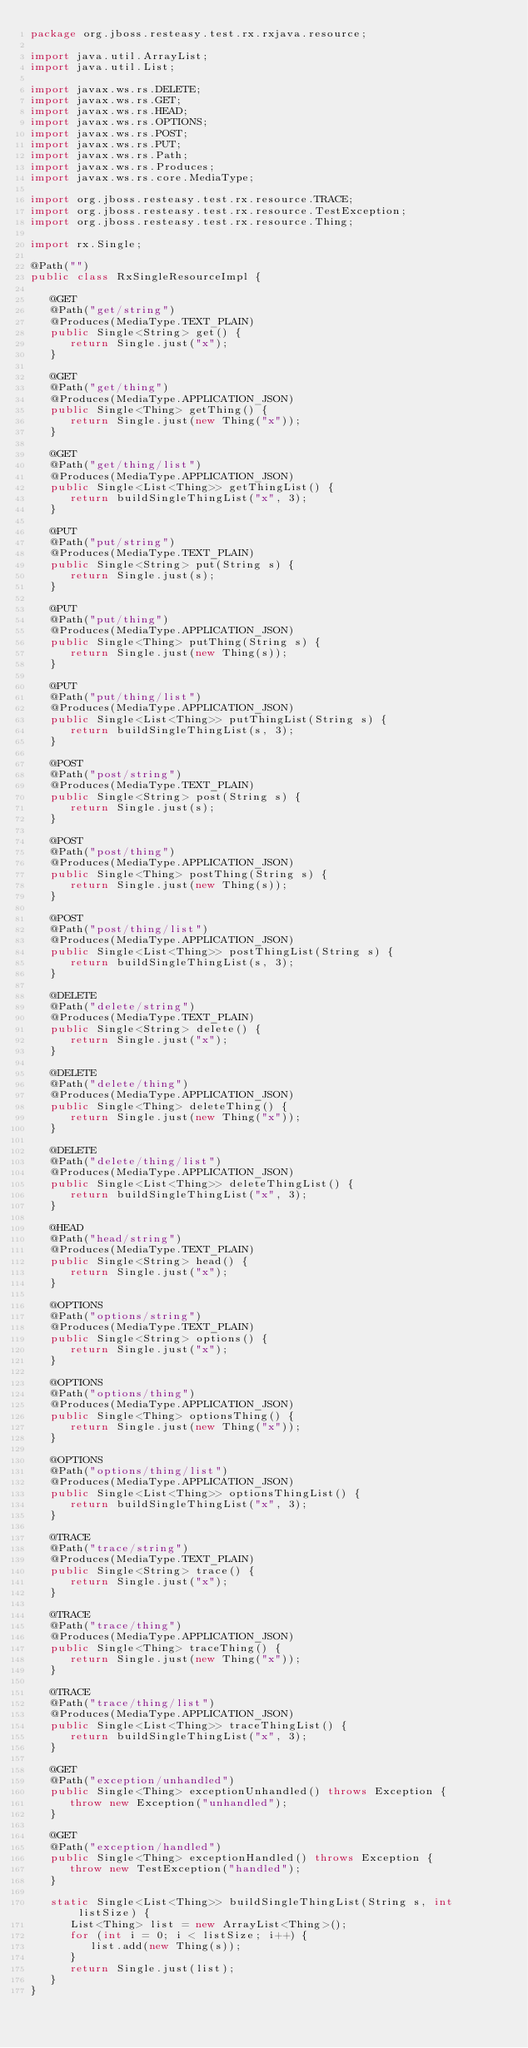<code> <loc_0><loc_0><loc_500><loc_500><_Java_>package org.jboss.resteasy.test.rx.rxjava.resource;

import java.util.ArrayList;
import java.util.List;

import javax.ws.rs.DELETE;
import javax.ws.rs.GET;
import javax.ws.rs.HEAD;
import javax.ws.rs.OPTIONS;
import javax.ws.rs.POST;
import javax.ws.rs.PUT;
import javax.ws.rs.Path;
import javax.ws.rs.Produces;
import javax.ws.rs.core.MediaType;

import org.jboss.resteasy.test.rx.resource.TRACE;
import org.jboss.resteasy.test.rx.resource.TestException;
import org.jboss.resteasy.test.rx.resource.Thing;

import rx.Single;

@Path("")
public class RxSingleResourceImpl {

   @GET
   @Path("get/string")
   @Produces(MediaType.TEXT_PLAIN)
   public Single<String> get() {
      return Single.just("x");
   }

   @GET
   @Path("get/thing")
   @Produces(MediaType.APPLICATION_JSON)
   public Single<Thing> getThing() {
      return Single.just(new Thing("x"));
   }

   @GET
   @Path("get/thing/list")
   @Produces(MediaType.APPLICATION_JSON)
   public Single<List<Thing>> getThingList() {
      return buildSingleThingList("x", 3);
   }

   @PUT
   @Path("put/string")
   @Produces(MediaType.TEXT_PLAIN)
   public Single<String> put(String s) {
      return Single.just(s);
   }

   @PUT
   @Path("put/thing")
   @Produces(MediaType.APPLICATION_JSON)
   public Single<Thing> putThing(String s) {
      return Single.just(new Thing(s));
   }

   @PUT
   @Path("put/thing/list")
   @Produces(MediaType.APPLICATION_JSON)
   public Single<List<Thing>> putThingList(String s) {
      return buildSingleThingList(s, 3);
   }

   @POST
   @Path("post/string")
   @Produces(MediaType.TEXT_PLAIN)
   public Single<String> post(String s) {
      return Single.just(s);
   }

   @POST
   @Path("post/thing")
   @Produces(MediaType.APPLICATION_JSON)
   public Single<Thing> postThing(String s) {
      return Single.just(new Thing(s));
   }

   @POST
   @Path("post/thing/list")
   @Produces(MediaType.APPLICATION_JSON)
   public Single<List<Thing>> postThingList(String s) {
      return buildSingleThingList(s, 3);
   }

   @DELETE
   @Path("delete/string")
   @Produces(MediaType.TEXT_PLAIN)
   public Single<String> delete() {
      return Single.just("x");
   }

   @DELETE
   @Path("delete/thing")
   @Produces(MediaType.APPLICATION_JSON)
   public Single<Thing> deleteThing() {
      return Single.just(new Thing("x"));
   }

   @DELETE
   @Path("delete/thing/list")
   @Produces(MediaType.APPLICATION_JSON)
   public Single<List<Thing>> deleteThingList() {
      return buildSingleThingList("x", 3);
   }

   @HEAD
   @Path("head/string")
   @Produces(MediaType.TEXT_PLAIN)
   public Single<String> head() {
      return Single.just("x");
   }

   @OPTIONS
   @Path("options/string")
   @Produces(MediaType.TEXT_PLAIN)
   public Single<String> options() {
      return Single.just("x");
   }

   @OPTIONS
   @Path("options/thing")
   @Produces(MediaType.APPLICATION_JSON)
   public Single<Thing> optionsThing() {
      return Single.just(new Thing("x"));
   }

   @OPTIONS
   @Path("options/thing/list")
   @Produces(MediaType.APPLICATION_JSON)
   public Single<List<Thing>> optionsThingList() {
      return buildSingleThingList("x", 3);
   }

   @TRACE
   @Path("trace/string")
   @Produces(MediaType.TEXT_PLAIN)
   public Single<String> trace() {
      return Single.just("x");
   }

   @TRACE
   @Path("trace/thing")
   @Produces(MediaType.APPLICATION_JSON)
   public Single<Thing> traceThing() {
      return Single.just(new Thing("x"));
   }

   @TRACE
   @Path("trace/thing/list")
   @Produces(MediaType.APPLICATION_JSON)
   public Single<List<Thing>> traceThingList() {
      return buildSingleThingList("x", 3);
   }
   
   @GET
   @Path("exception/unhandled")
   public Single<Thing> exceptionUnhandled() throws Exception {
      throw new Exception("unhandled");
   }
   
   @GET
   @Path("exception/handled")
   public Single<Thing> exceptionHandled() throws Exception {
      throw new TestException("handled");
   }

   static Single<List<Thing>> buildSingleThingList(String s, int listSize) {
      List<Thing> list = new ArrayList<Thing>();
      for (int i = 0; i < listSize; i++) {
         list.add(new Thing(s));
      }
      return Single.just(list);
   }
}
</code> 